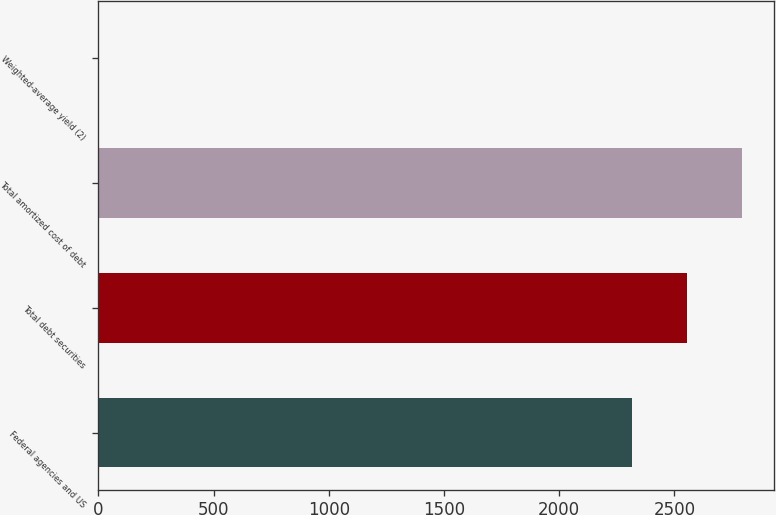Convert chart. <chart><loc_0><loc_0><loc_500><loc_500><bar_chart><fcel>Federal agencies and US<fcel>Total debt securities<fcel>Total amortized cost of debt<fcel>Weighted-average yield (2)<nl><fcel>2318<fcel>2555.32<fcel>2792.64<fcel>1.76<nl></chart> 